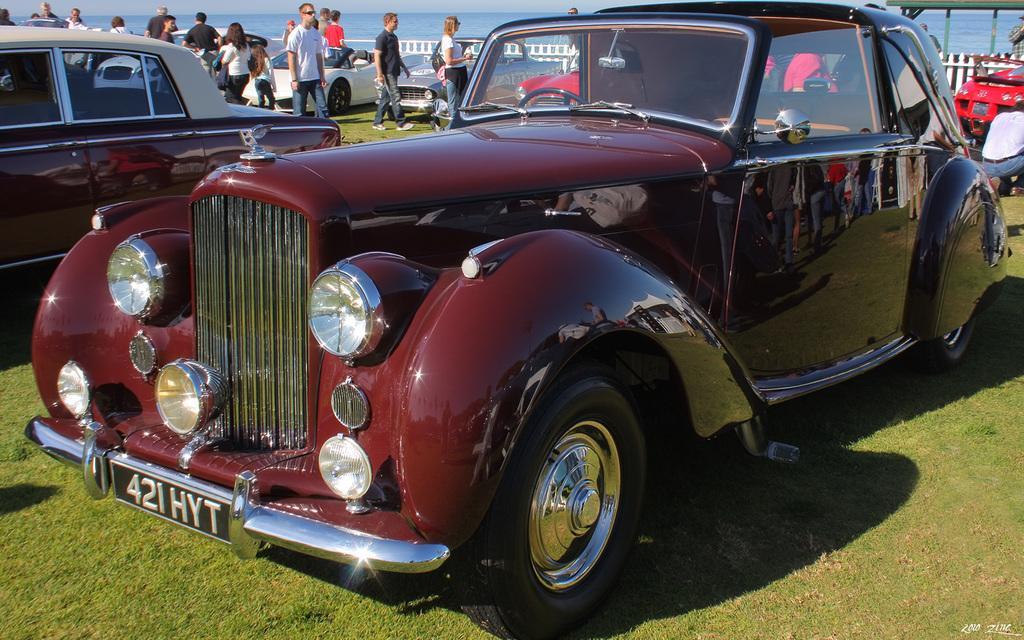In one or two sentences, can you explain what this image depicts? As we can see in the image there are different colors of cars, grass, group of people, fence and in the background there is water. 